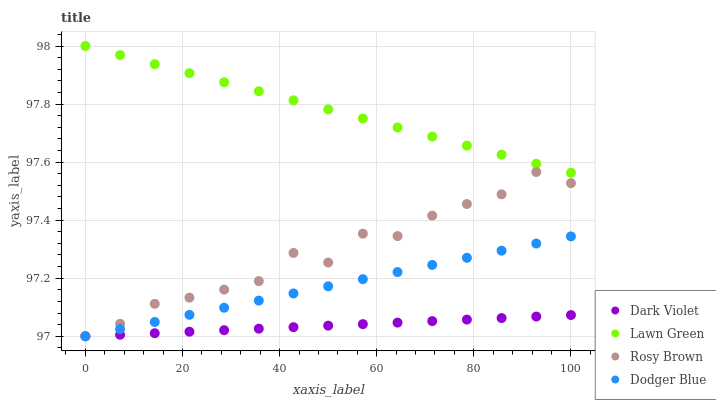Does Dark Violet have the minimum area under the curve?
Answer yes or no. Yes. Does Lawn Green have the maximum area under the curve?
Answer yes or no. Yes. Does Rosy Brown have the minimum area under the curve?
Answer yes or no. No. Does Rosy Brown have the maximum area under the curve?
Answer yes or no. No. Is Dodger Blue the smoothest?
Answer yes or no. Yes. Is Rosy Brown the roughest?
Answer yes or no. Yes. Is Rosy Brown the smoothest?
Answer yes or no. No. Is Dodger Blue the roughest?
Answer yes or no. No. Does Rosy Brown have the lowest value?
Answer yes or no. Yes. Does Lawn Green have the highest value?
Answer yes or no. Yes. Does Rosy Brown have the highest value?
Answer yes or no. No. Is Rosy Brown less than Lawn Green?
Answer yes or no. Yes. Is Lawn Green greater than Dodger Blue?
Answer yes or no. Yes. Does Dodger Blue intersect Rosy Brown?
Answer yes or no. Yes. Is Dodger Blue less than Rosy Brown?
Answer yes or no. No. Is Dodger Blue greater than Rosy Brown?
Answer yes or no. No. Does Rosy Brown intersect Lawn Green?
Answer yes or no. No. 